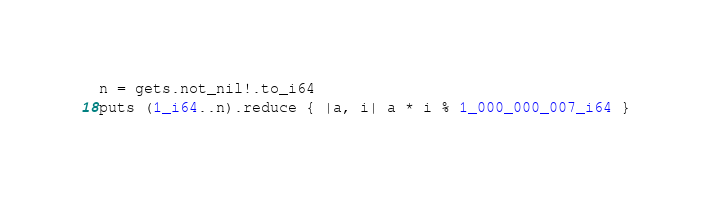Convert code to text. <code><loc_0><loc_0><loc_500><loc_500><_Crystal_>n = gets.not_nil!.to_i64
puts (1_i64..n).reduce { |a, i| a * i % 1_000_000_007_i64 }
</code> 